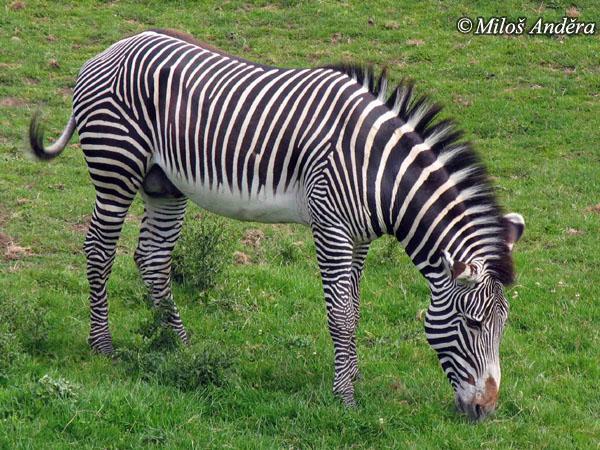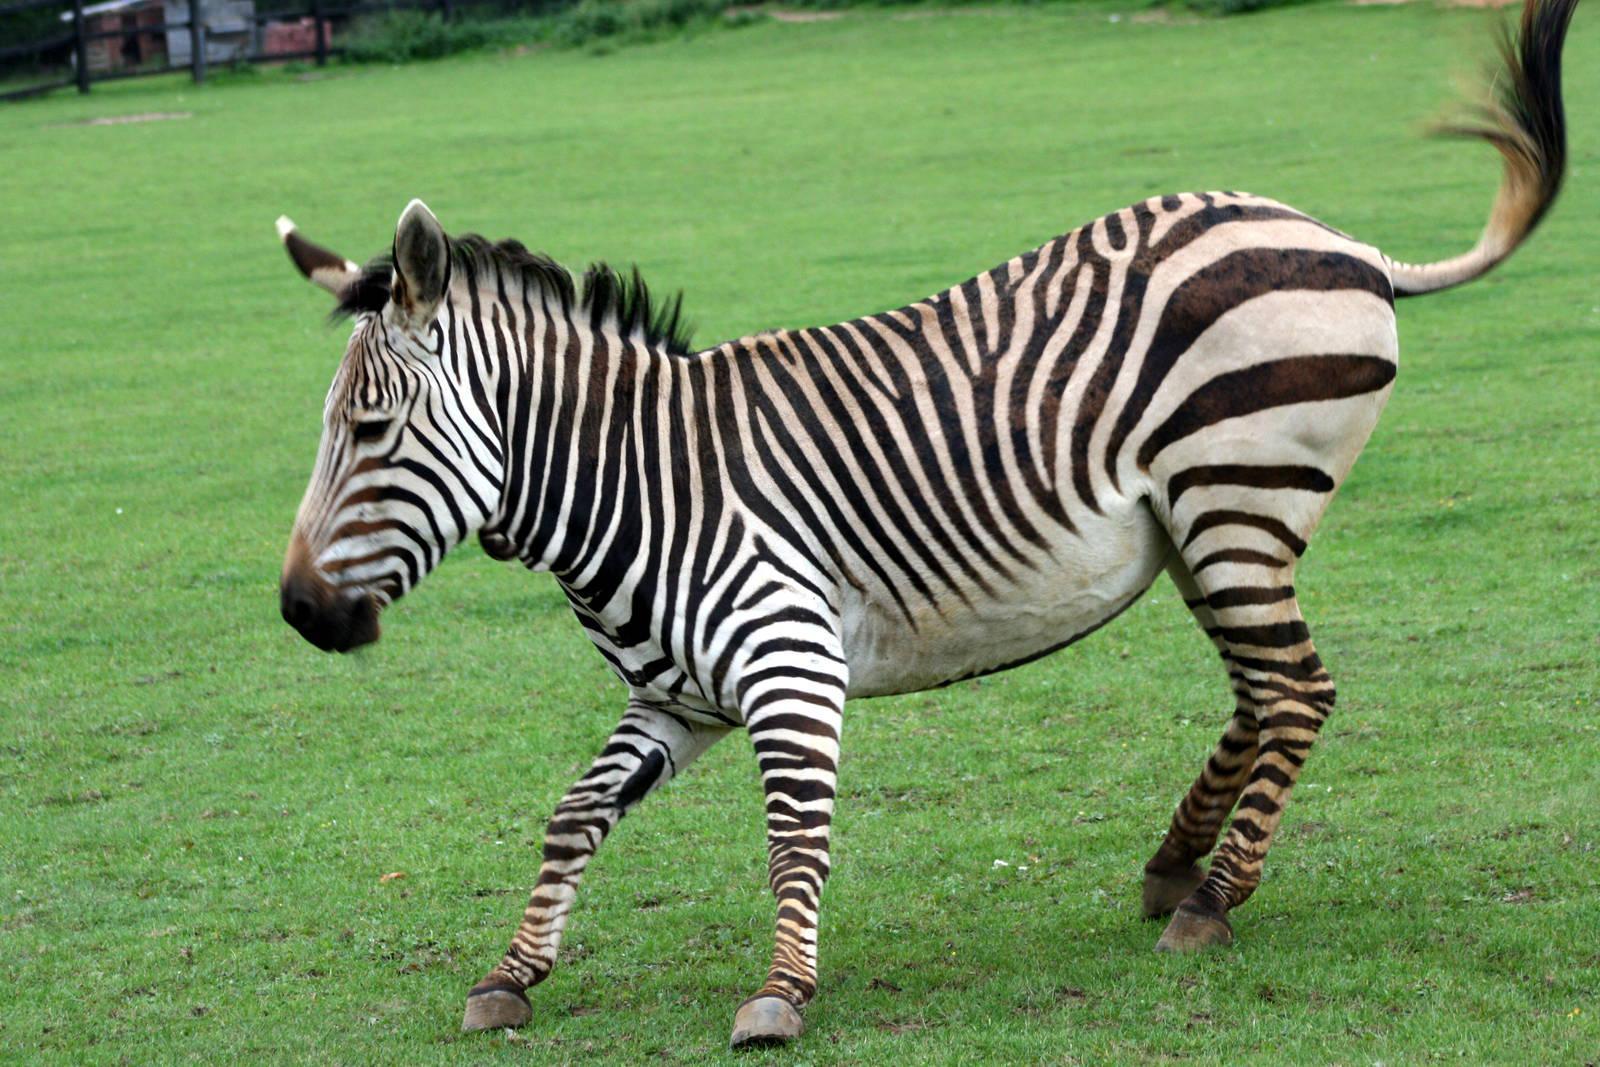The first image is the image on the left, the second image is the image on the right. Given the left and right images, does the statement "The left image shows exactly two zebras while the right image shows exactly one." hold true? Answer yes or no. No. The first image is the image on the left, the second image is the image on the right. For the images shown, is this caption "The images contain a total of three zebras." true? Answer yes or no. No. 